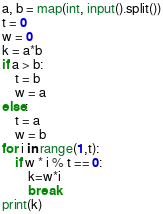Convert code to text. <code><loc_0><loc_0><loc_500><loc_500><_Python_>a, b = map(int, input().split())
t = 0
w = 0
k = a*b
if a > b:
    t = b
    w = a
else:
    t = a
    w = b
for i in range(1,t):
    if w * i % t == 0:
        k=w*i
        break
print(k)</code> 